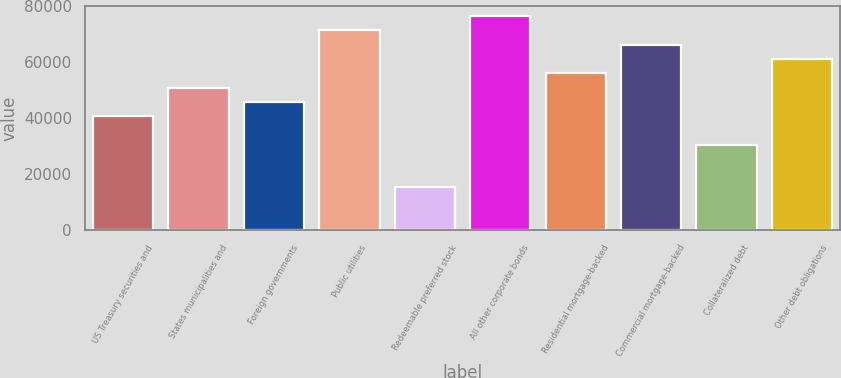Convert chart. <chart><loc_0><loc_0><loc_500><loc_500><bar_chart><fcel>US Treasury securities and<fcel>States municipalities and<fcel>Foreign governments<fcel>Public utilities<fcel>Redeemable preferred stock<fcel>All other corporate bonds<fcel>Residential mortgage-backed<fcel>Commercial mortgage-backed<fcel>Collateralized debt<fcel>Other debt obligations<nl><fcel>40753<fcel>50939.3<fcel>45846.1<fcel>71311.9<fcel>15287.2<fcel>76405.1<fcel>56032.5<fcel>66218.8<fcel>30566.7<fcel>61125.6<nl></chart> 